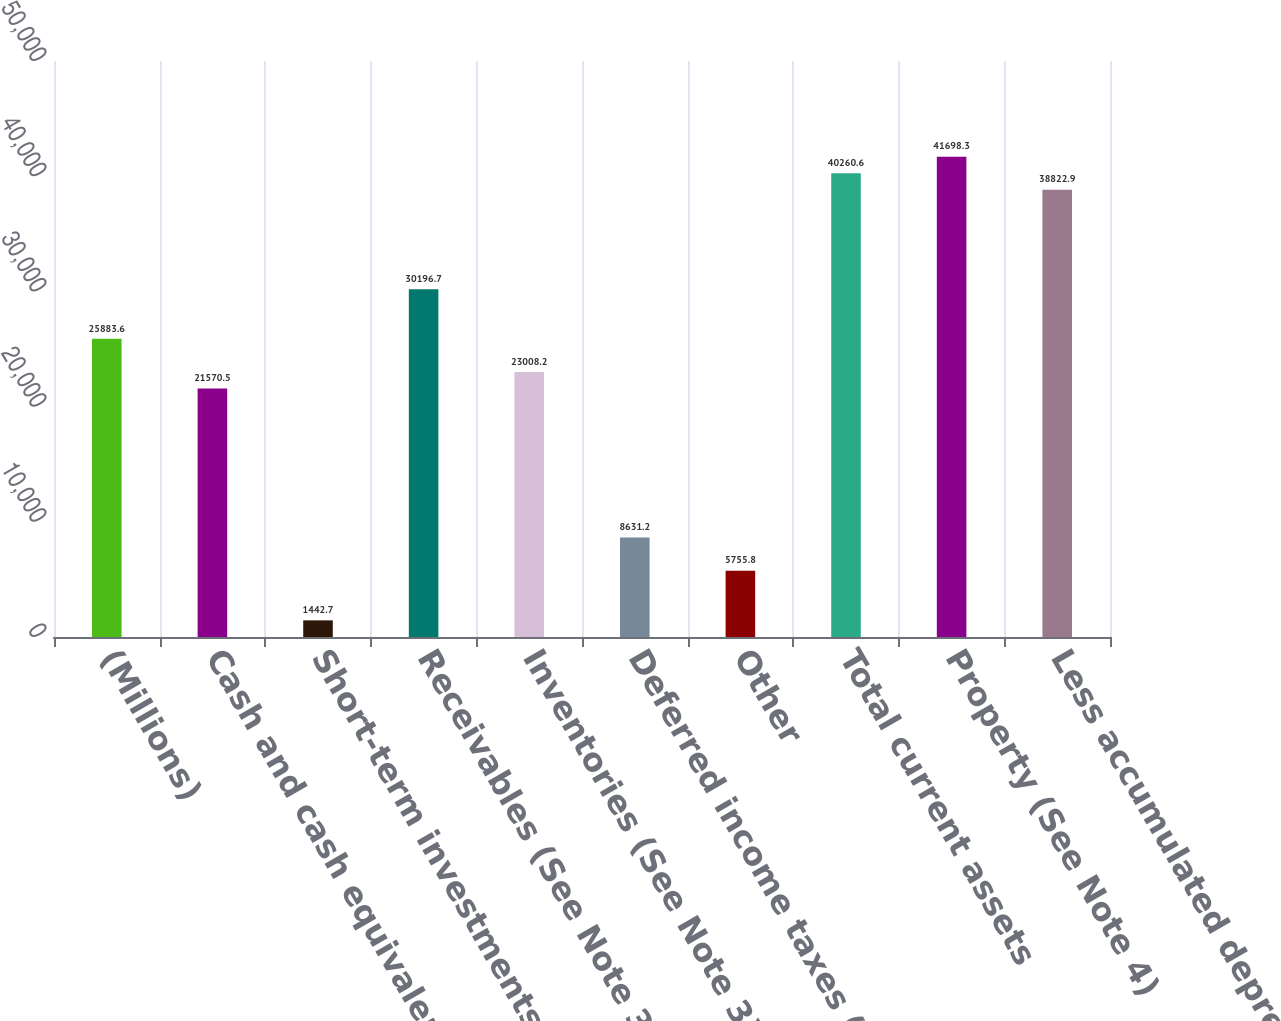Convert chart. <chart><loc_0><loc_0><loc_500><loc_500><bar_chart><fcel>(Millions)<fcel>Cash and cash equivalents<fcel>Short-term investments (See<fcel>Receivables (See Note 3)<fcel>Inventories (See Note 3)<fcel>Deferred income taxes (See<fcel>Other<fcel>Total current assets<fcel>Property (See Note 4)<fcel>Less accumulated depreciation<nl><fcel>25883.6<fcel>21570.5<fcel>1442.7<fcel>30196.7<fcel>23008.2<fcel>8631.2<fcel>5755.8<fcel>40260.6<fcel>41698.3<fcel>38822.9<nl></chart> 